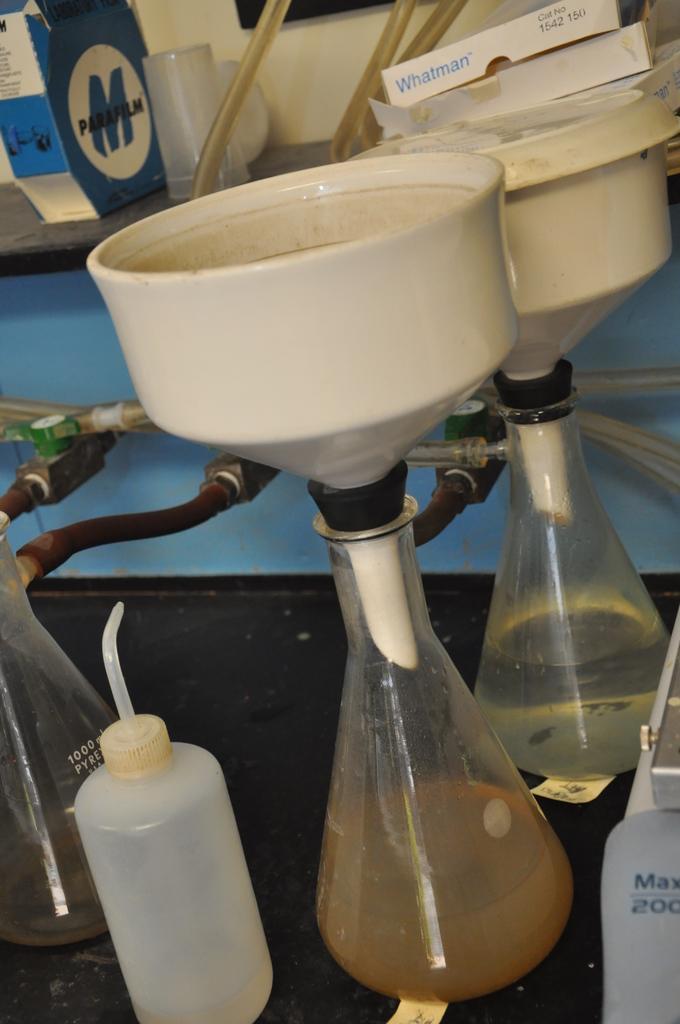Could you give a brief overview of what you see in this image? This is a picture of a laboratory equipments. 